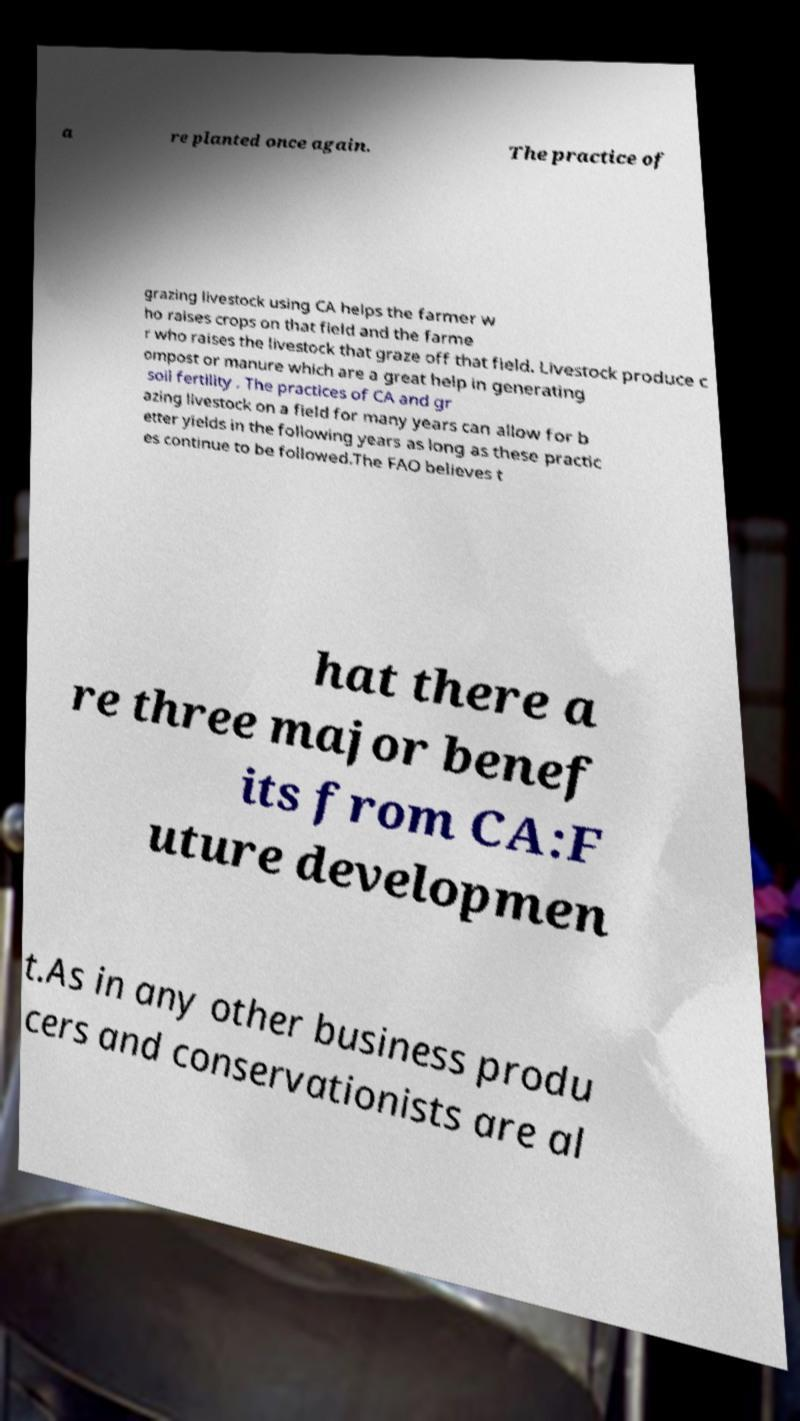There's text embedded in this image that I need extracted. Can you transcribe it verbatim? a re planted once again. The practice of grazing livestock using CA helps the farmer w ho raises crops on that field and the farme r who raises the livestock that graze off that field. Livestock produce c ompost or manure which are a great help in generating soil fertility . The practices of CA and gr azing livestock on a field for many years can allow for b etter yields in the following years as long as these practic es continue to be followed.The FAO believes t hat there a re three major benef its from CA:F uture developmen t.As in any other business produ cers and conservationists are al 